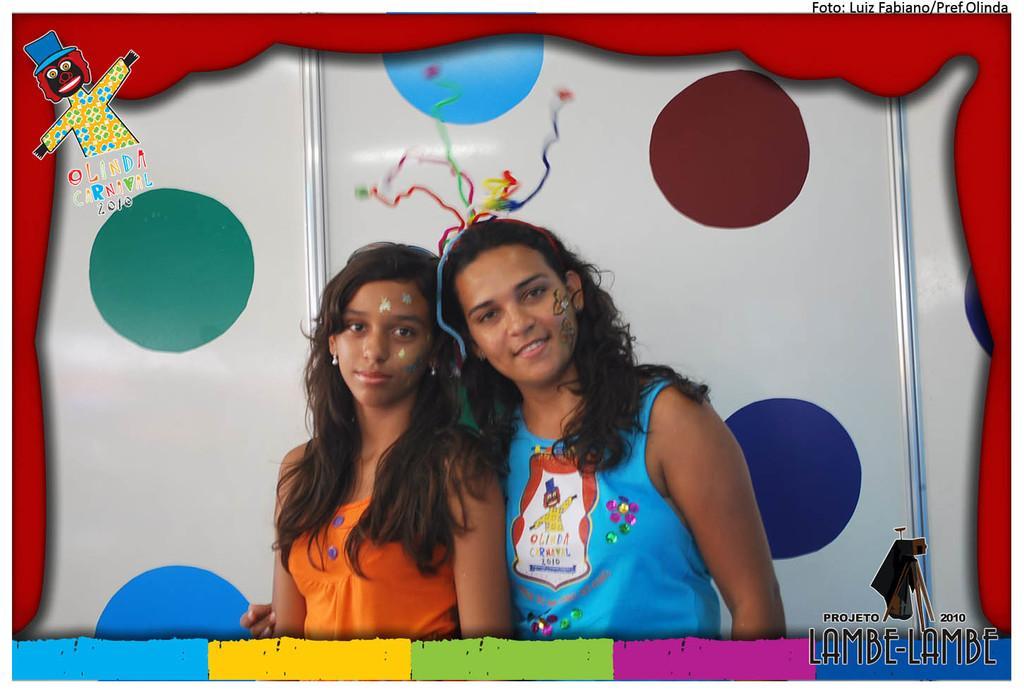Please provide a concise description of this image. In this image there are two girls with a smile on their faces. Behind them there are colored dots. On top and bottom of the image there is some text. On the left side of the image there is a depiction of a person with some text. 